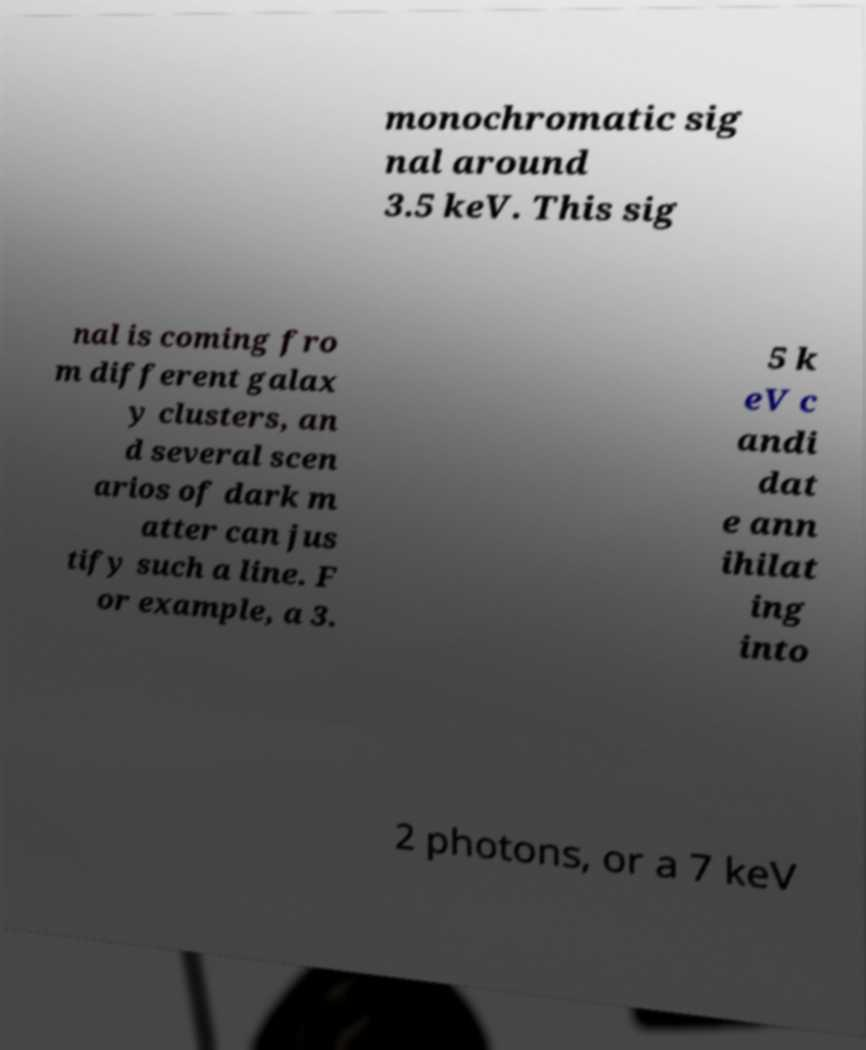Can you read and provide the text displayed in the image?This photo seems to have some interesting text. Can you extract and type it out for me? monochromatic sig nal around 3.5 keV. This sig nal is coming fro m different galax y clusters, an d several scen arios of dark m atter can jus tify such a line. F or example, a 3. 5 k eV c andi dat e ann ihilat ing into 2 photons, or a 7 keV 